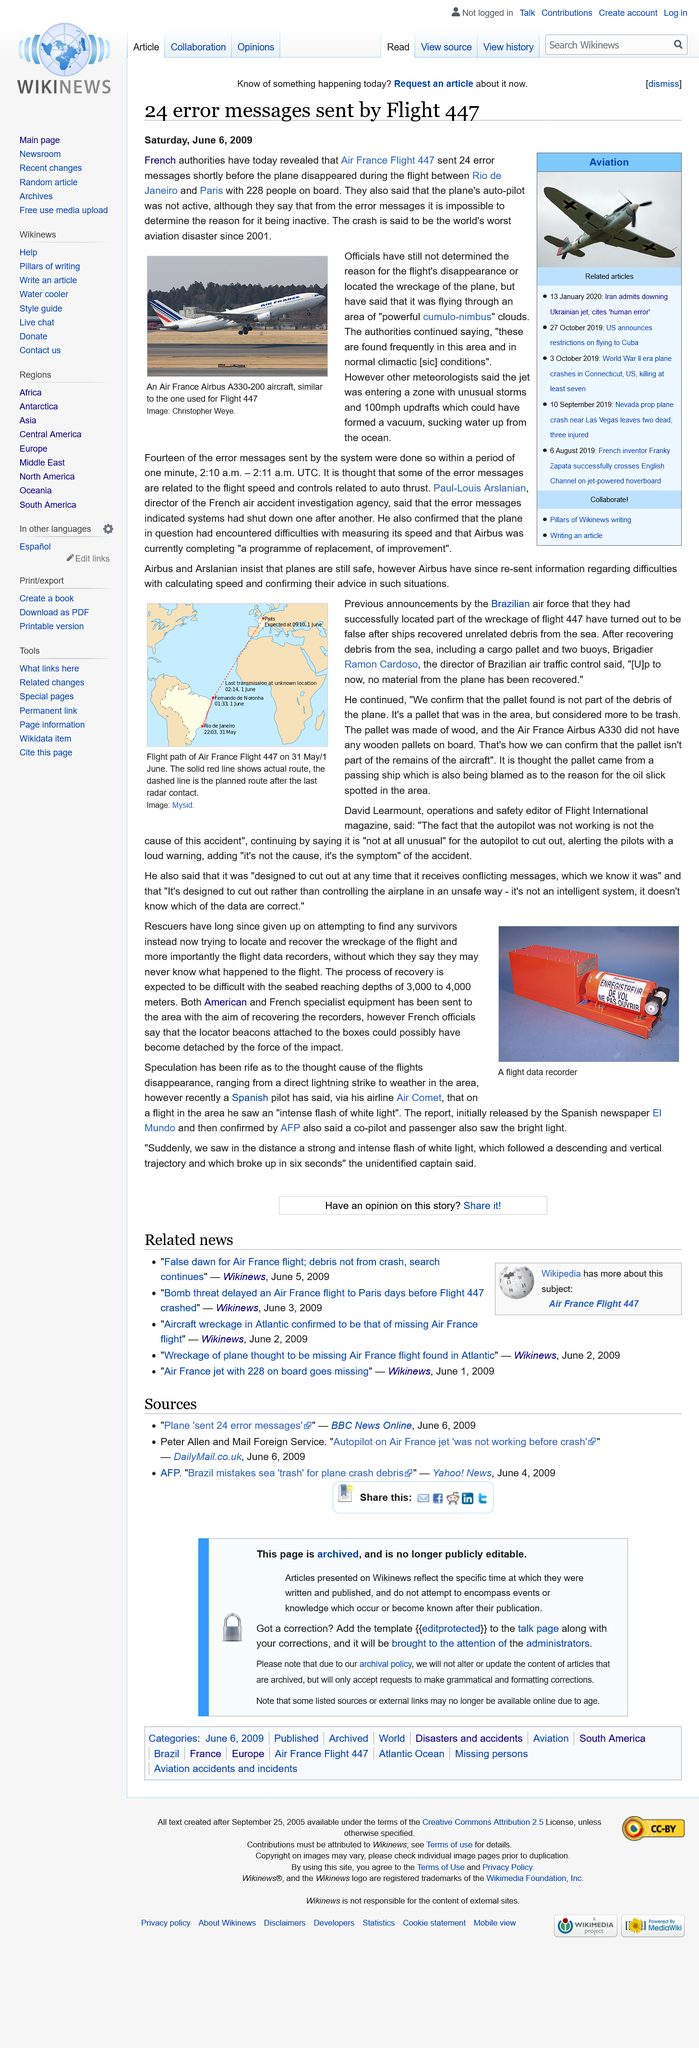Identify some key points in this picture. The pilot who reported seeing an intense flash of white light belonged to Air Comet. I, David Learmount, am the operations and safety editor of Flight Internation magazine. According to French officials, the locator beacons attached to the records could have become detached as a result of the impact's force, leading to their possible loss or detachment. The Air France Flight 447 sent 24 error messages. The autopilot not working was not the cause of the accident, as David Learmount stated. 